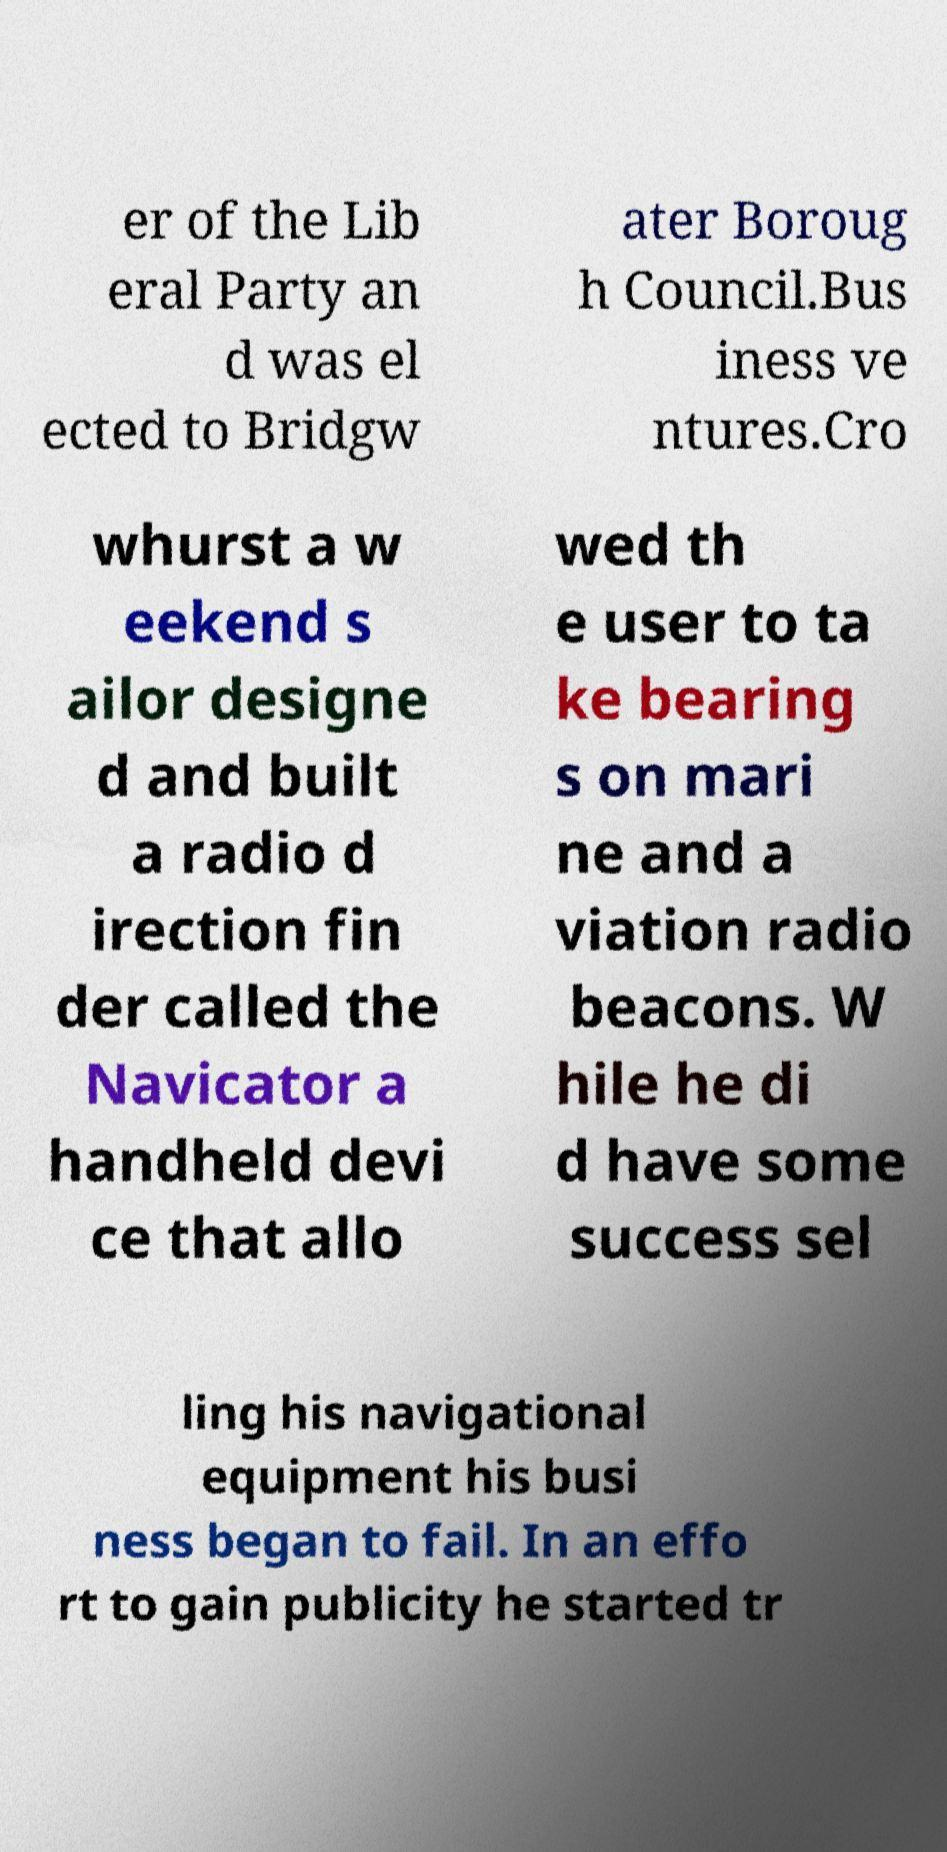What messages or text are displayed in this image? I need them in a readable, typed format. er of the Lib eral Party an d was el ected to Bridgw ater Boroug h Council.Bus iness ve ntures.Cro whurst a w eekend s ailor designe d and built a radio d irection fin der called the Navicator a handheld devi ce that allo wed th e user to ta ke bearing s on mari ne and a viation radio beacons. W hile he di d have some success sel ling his navigational equipment his busi ness began to fail. In an effo rt to gain publicity he started tr 